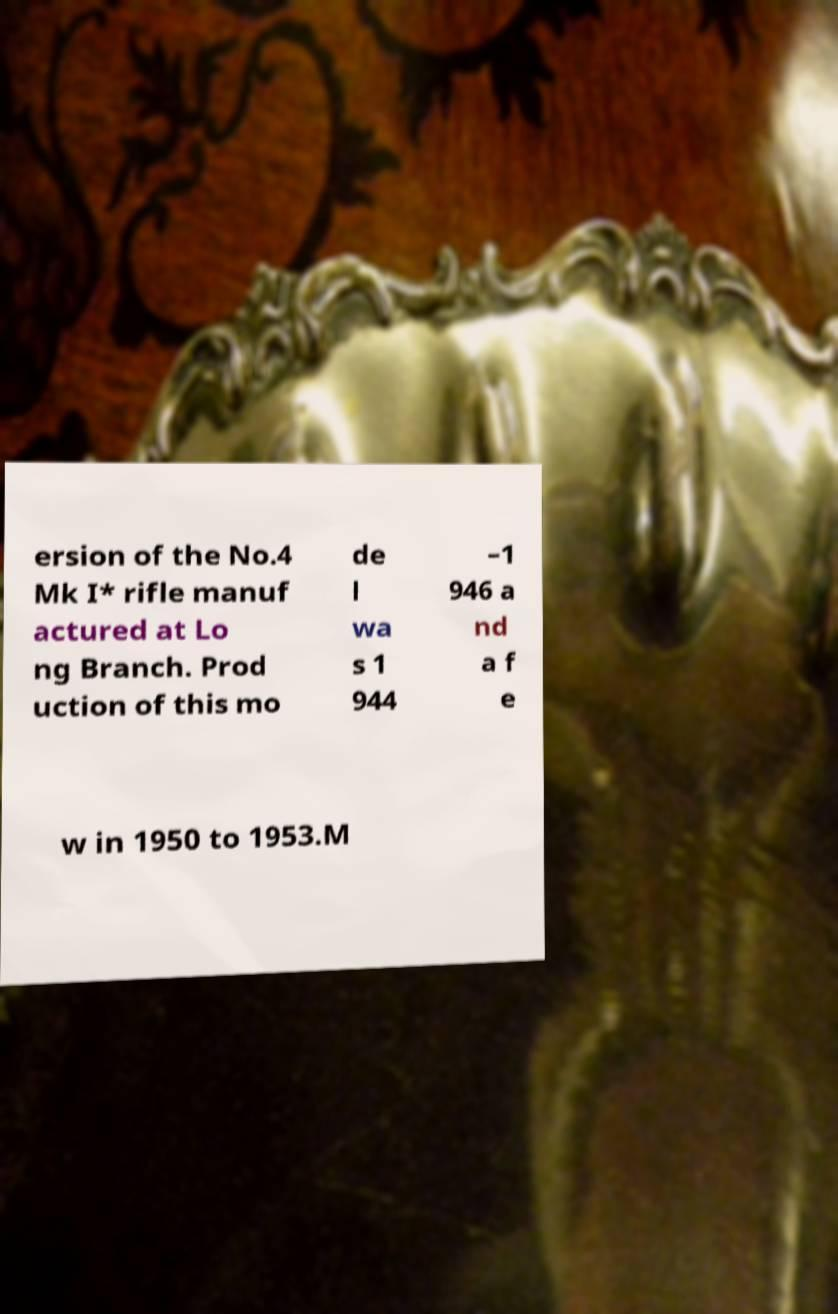Could you assist in decoding the text presented in this image and type it out clearly? ersion of the No.4 Mk I* rifle manuf actured at Lo ng Branch. Prod uction of this mo de l wa s 1 944 –1 946 a nd a f e w in 1950 to 1953.M 